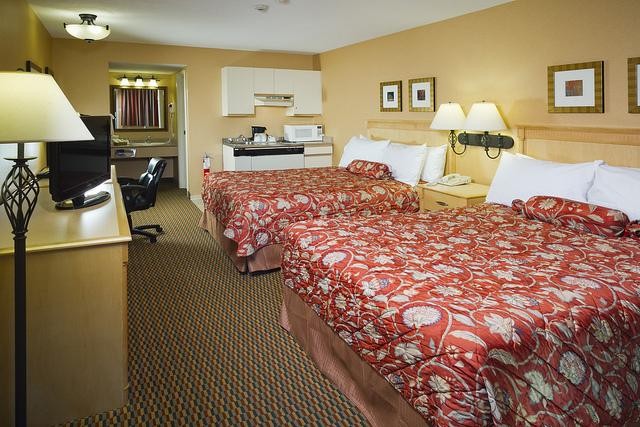Who would stay in this room? tourist 